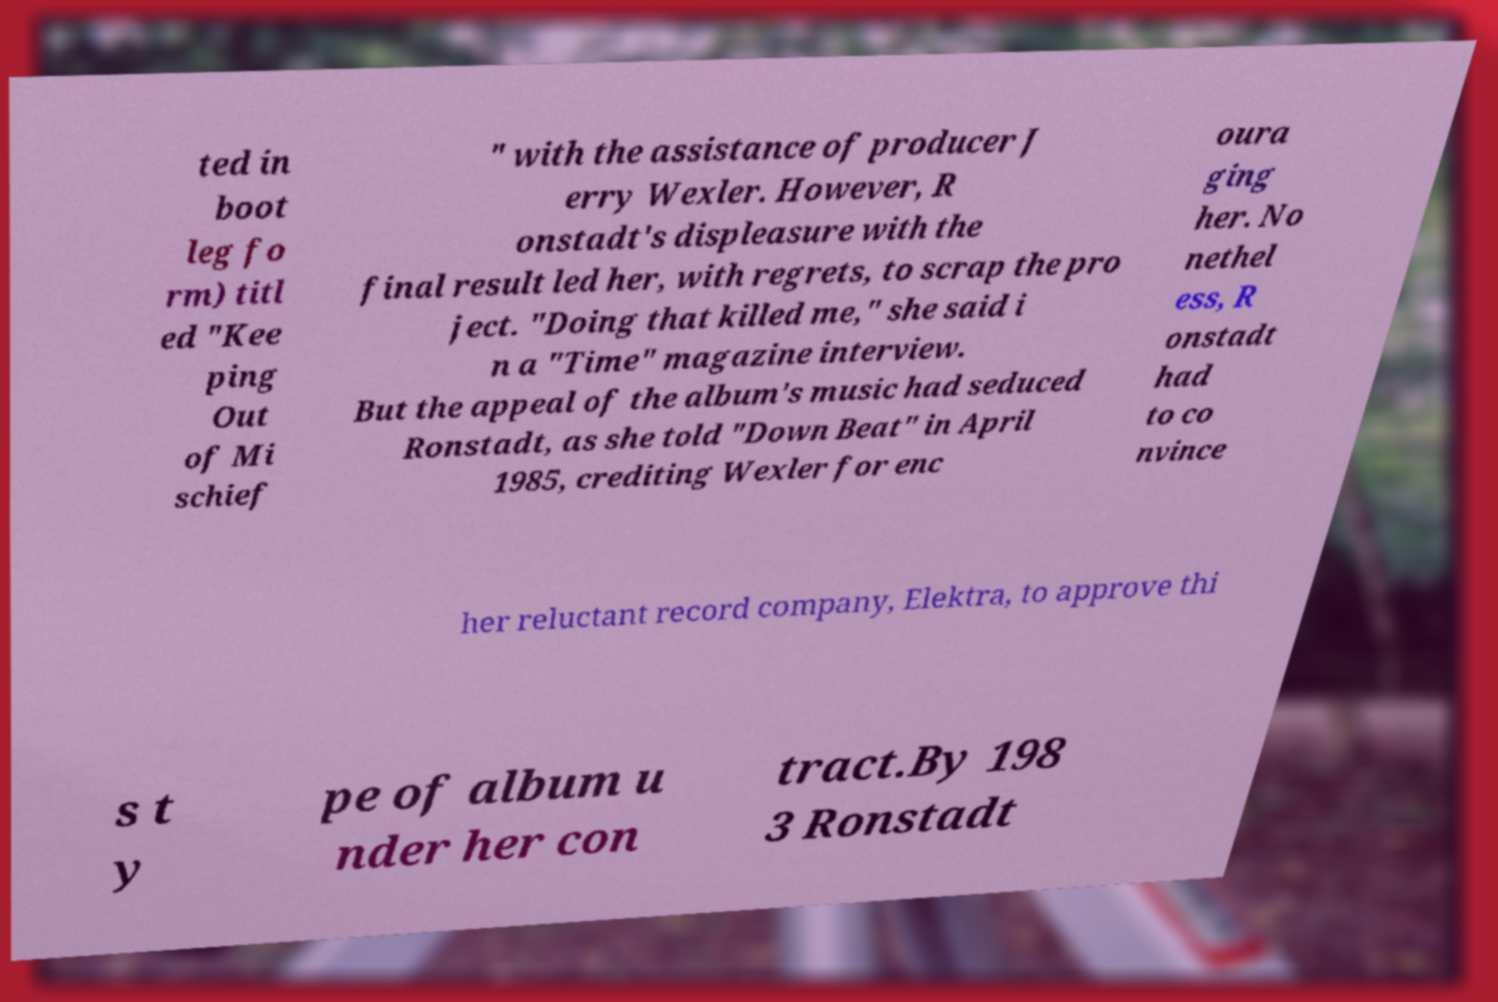For documentation purposes, I need the text within this image transcribed. Could you provide that? ted in boot leg fo rm) titl ed "Kee ping Out of Mi schief " with the assistance of producer J erry Wexler. However, R onstadt's displeasure with the final result led her, with regrets, to scrap the pro ject. "Doing that killed me," she said i n a "Time" magazine interview. But the appeal of the album's music had seduced Ronstadt, as she told "Down Beat" in April 1985, crediting Wexler for enc oura ging her. No nethel ess, R onstadt had to co nvince her reluctant record company, Elektra, to approve thi s t y pe of album u nder her con tract.By 198 3 Ronstadt 